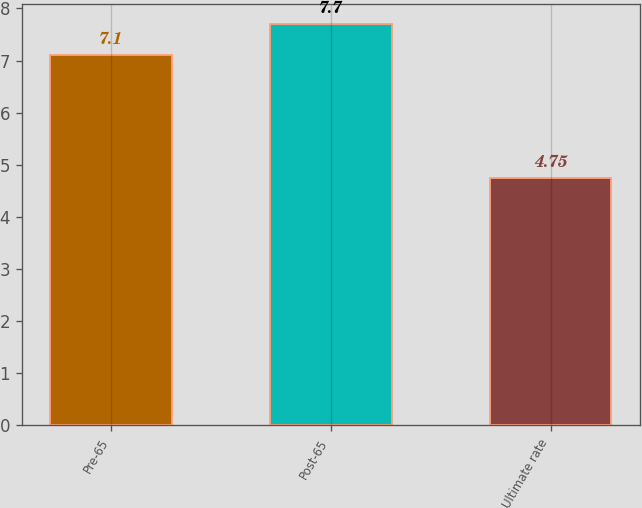<chart> <loc_0><loc_0><loc_500><loc_500><bar_chart><fcel>Pre-65<fcel>Post-65<fcel>Ultimate rate<nl><fcel>7.1<fcel>7.7<fcel>4.75<nl></chart> 